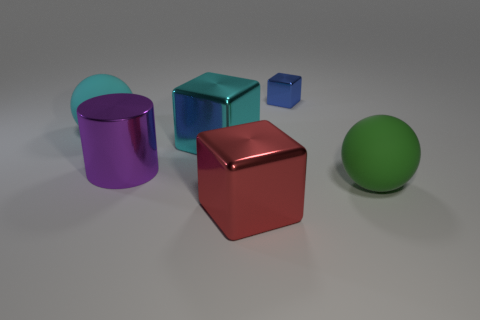Add 2 big red shiny objects. How many objects exist? 8 Subtract all cylinders. How many objects are left? 5 Add 3 big metal blocks. How many big metal blocks exist? 5 Subtract 0 red cylinders. How many objects are left? 6 Subtract all big red cylinders. Subtract all green objects. How many objects are left? 5 Add 2 big purple shiny things. How many big purple shiny things are left? 3 